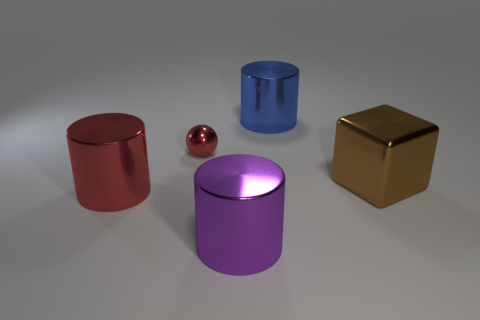The tiny red object that is made of the same material as the large red thing is what shape?
Give a very brief answer. Sphere. What number of other objects are there of the same material as the big purple thing?
Offer a very short reply. 4. What number of objects are either metal things that are to the right of the ball or metal cylinders behind the red shiny cylinder?
Give a very brief answer. 3. Does the metallic object to the right of the big blue metallic cylinder have the same shape as the object in front of the large red thing?
Your response must be concise. No. What is the shape of the red thing that is the same size as the purple metallic object?
Keep it short and to the point. Cylinder. What number of shiny objects are big red cylinders or small balls?
Keep it short and to the point. 2. What is the color of the cube that is the same material as the sphere?
Your response must be concise. Brown. Is the number of objects to the left of the red sphere greater than the number of blue shiny objects that are to the left of the purple shiny thing?
Your answer should be very brief. Yes. Are any tiny gray matte cylinders visible?
Ensure brevity in your answer.  No. There is a large cylinder that is the same color as the metallic ball; what is its material?
Provide a succinct answer. Metal. 